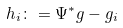Convert formula to latex. <formula><loc_0><loc_0><loc_500><loc_500>h _ { i } \colon = \Psi ^ { * } g - g _ { i }</formula> 